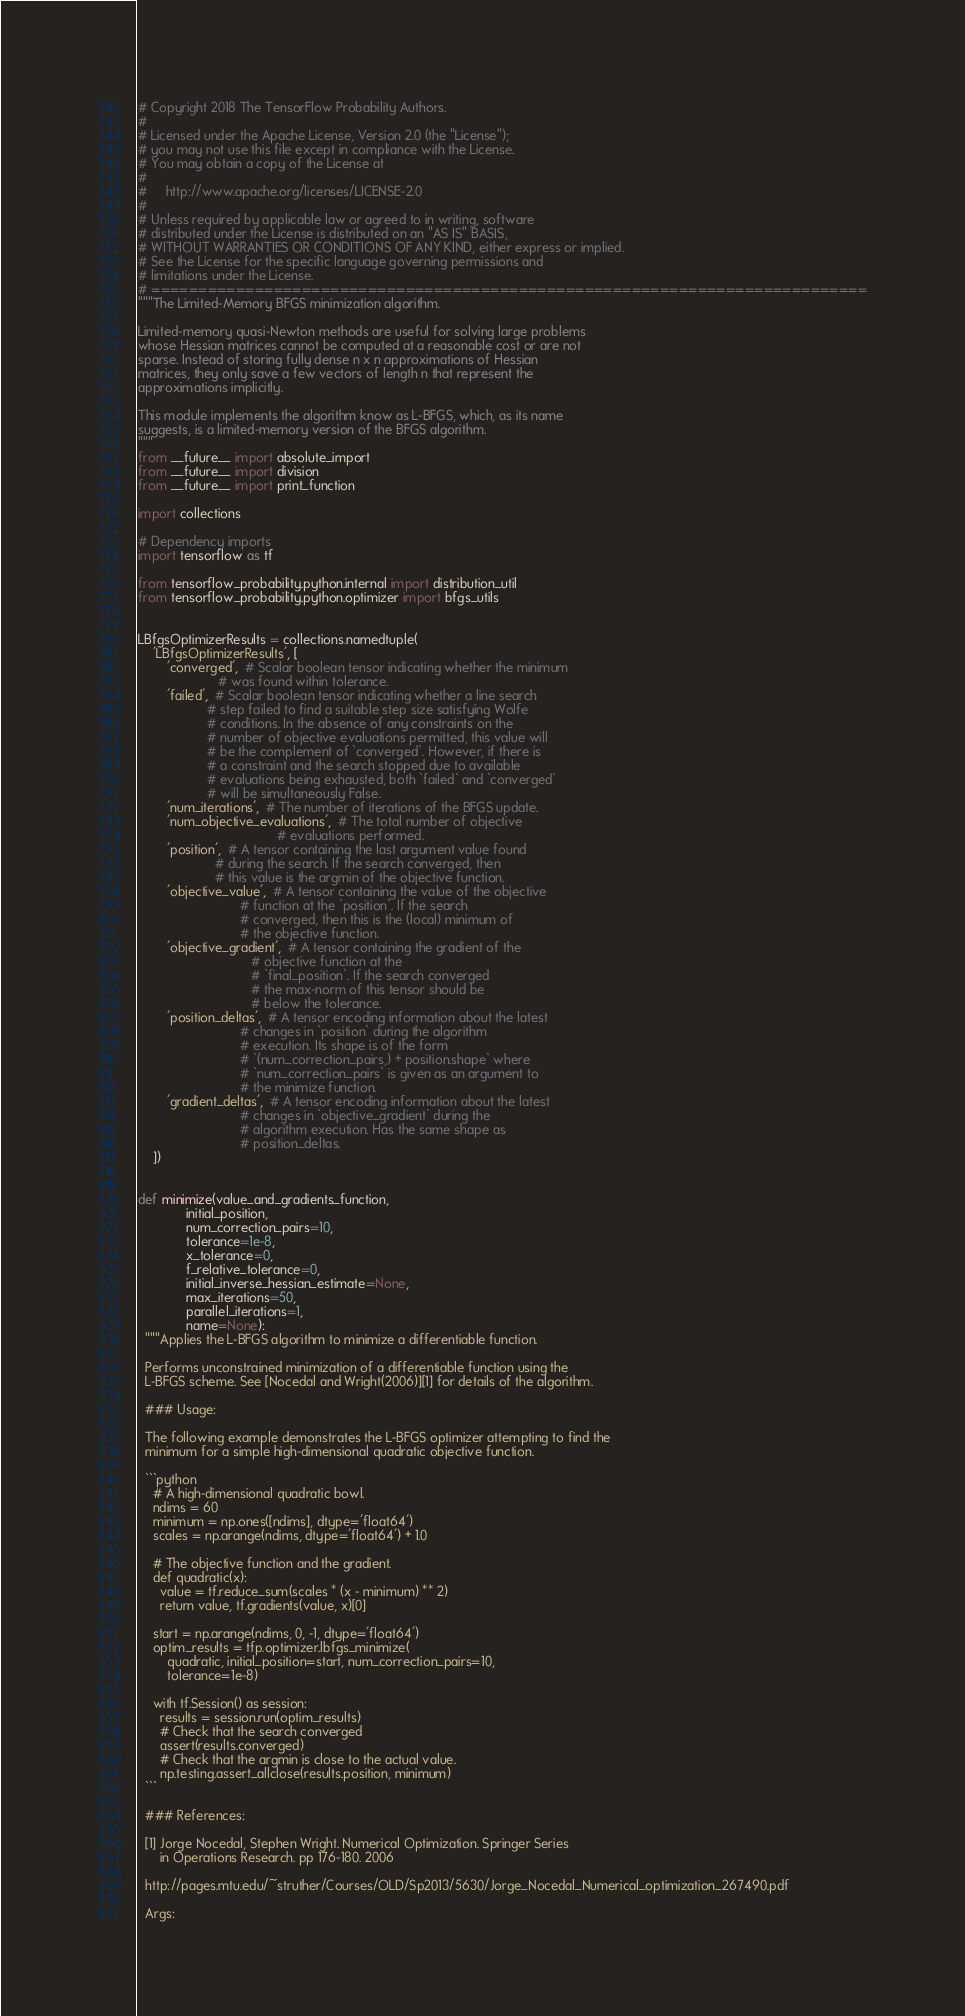<code> <loc_0><loc_0><loc_500><loc_500><_Python_># Copyright 2018 The TensorFlow Probability Authors.
#
# Licensed under the Apache License, Version 2.0 (the "License");
# you may not use this file except in compliance with the License.
# You may obtain a copy of the License at
#
#     http://www.apache.org/licenses/LICENSE-2.0
#
# Unless required by applicable law or agreed to in writing, software
# distributed under the License is distributed on an "AS IS" BASIS,
# WITHOUT WARRANTIES OR CONDITIONS OF ANY KIND, either express or implied.
# See the License for the specific language governing permissions and
# limitations under the License.
# ============================================================================
"""The Limited-Memory BFGS minimization algorithm.

Limited-memory quasi-Newton methods are useful for solving large problems
whose Hessian matrices cannot be computed at a reasonable cost or are not
sparse. Instead of storing fully dense n x n approximations of Hessian
matrices, they only save a few vectors of length n that represent the
approximations implicitly.

This module implements the algorithm know as L-BFGS, which, as its name
suggests, is a limited-memory version of the BFGS algorithm.
"""
from __future__ import absolute_import
from __future__ import division
from __future__ import print_function

import collections

# Dependency imports
import tensorflow as tf

from tensorflow_probability.python.internal import distribution_util
from tensorflow_probability.python.optimizer import bfgs_utils


LBfgsOptimizerResults = collections.namedtuple(
    'LBfgsOptimizerResults', [
        'converged',  # Scalar boolean tensor indicating whether the minimum
                      # was found within tolerance.
        'failed',  # Scalar boolean tensor indicating whether a line search
                   # step failed to find a suitable step size satisfying Wolfe
                   # conditions. In the absence of any constraints on the
                   # number of objective evaluations permitted, this value will
                   # be the complement of `converged`. However, if there is
                   # a constraint and the search stopped due to available
                   # evaluations being exhausted, both `failed` and `converged`
                   # will be simultaneously False.
        'num_iterations',  # The number of iterations of the BFGS update.
        'num_objective_evaluations',  # The total number of objective
                                      # evaluations performed.
        'position',  # A tensor containing the last argument value found
                     # during the search. If the search converged, then
                     # this value is the argmin of the objective function.
        'objective_value',  # A tensor containing the value of the objective
                            # function at the `position`. If the search
                            # converged, then this is the (local) minimum of
                            # the objective function.
        'objective_gradient',  # A tensor containing the gradient of the
                               # objective function at the
                               # `final_position`. If the search converged
                               # the max-norm of this tensor should be
                               # below the tolerance.
        'position_deltas',  # A tensor encoding information about the latest
                            # changes in `position` during the algorithm
                            # execution. Its shape is of the form
                            # `(num_correction_pairs,) + position.shape` where
                            # `num_correction_pairs` is given as an argument to
                            # the minimize function.
        'gradient_deltas',  # A tensor encoding information about the latest
                            # changes in `objective_gradient` during the
                            # algorithm execution. Has the same shape as
                            # position_deltas.
    ])


def minimize(value_and_gradients_function,
             initial_position,
             num_correction_pairs=10,
             tolerance=1e-8,
             x_tolerance=0,
             f_relative_tolerance=0,
             initial_inverse_hessian_estimate=None,
             max_iterations=50,
             parallel_iterations=1,
             name=None):
  """Applies the L-BFGS algorithm to minimize a differentiable function.

  Performs unconstrained minimization of a differentiable function using the
  L-BFGS scheme. See [Nocedal and Wright(2006)][1] for details of the algorithm.

  ### Usage:

  The following example demonstrates the L-BFGS optimizer attempting to find the
  minimum for a simple high-dimensional quadratic objective function.

  ```python
    # A high-dimensional quadratic bowl.
    ndims = 60
    minimum = np.ones([ndims], dtype='float64')
    scales = np.arange(ndims, dtype='float64') + 1.0

    # The objective function and the gradient.
    def quadratic(x):
      value = tf.reduce_sum(scales * (x - minimum) ** 2)
      return value, tf.gradients(value, x)[0]

    start = np.arange(ndims, 0, -1, dtype='float64')
    optim_results = tfp.optimizer.lbfgs_minimize(
        quadratic, initial_position=start, num_correction_pairs=10,
        tolerance=1e-8)

    with tf.Session() as session:
      results = session.run(optim_results)
      # Check that the search converged
      assert(results.converged)
      # Check that the argmin is close to the actual value.
      np.testing.assert_allclose(results.position, minimum)
  ```

  ### References:

  [1] Jorge Nocedal, Stephen Wright. Numerical Optimization. Springer Series
      in Operations Research. pp 176-180. 2006

  http://pages.mtu.edu/~struther/Courses/OLD/Sp2013/5630/Jorge_Nocedal_Numerical_optimization_267490.pdf

  Args:</code> 